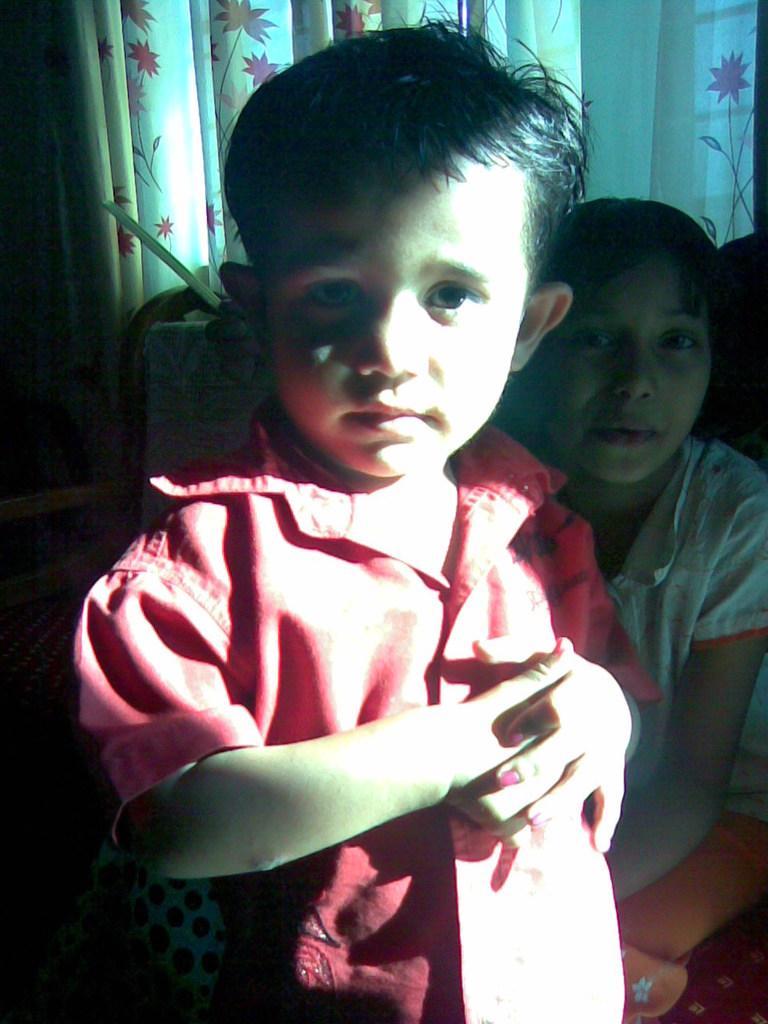Can you describe this image briefly? In this image I can see two children's. In front he is wearing red color dress. Back Side I can see colorful curtain. 